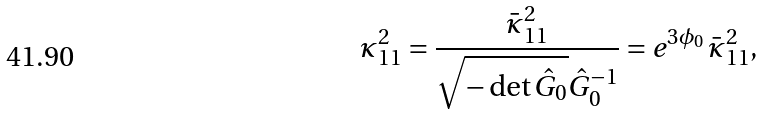<formula> <loc_0><loc_0><loc_500><loc_500>\kappa _ { 1 1 } ^ { 2 } = \frac { { \bar { \kappa } } _ { 1 1 } ^ { 2 } } { \sqrt { - \det \hat { G } _ { 0 } } { \hat { G } _ { 0 } } ^ { - 1 } } = e ^ { 3 \phi _ { 0 } } \, { \bar { \kappa } } _ { 1 1 } ^ { 2 } ,</formula> 